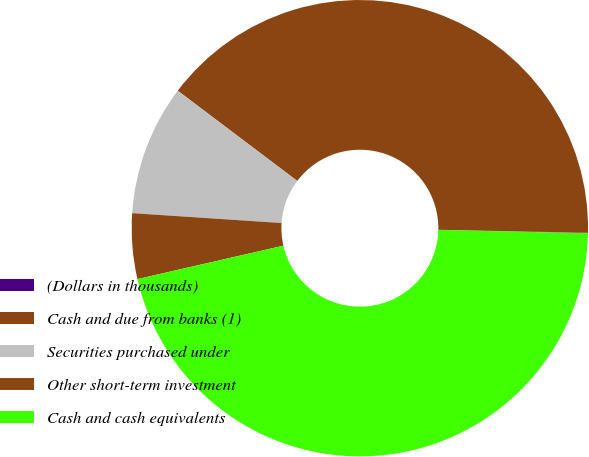Convert chart. <chart><loc_0><loc_0><loc_500><loc_500><pie_chart><fcel>(Dollars in thousands)<fcel>Cash and due from banks (1)<fcel>Securities purchased under<fcel>Other short-term investment<fcel>Cash and cash equivalents<nl><fcel>0.03%<fcel>40.03%<fcel>9.24%<fcel>4.63%<fcel>46.07%<nl></chart> 